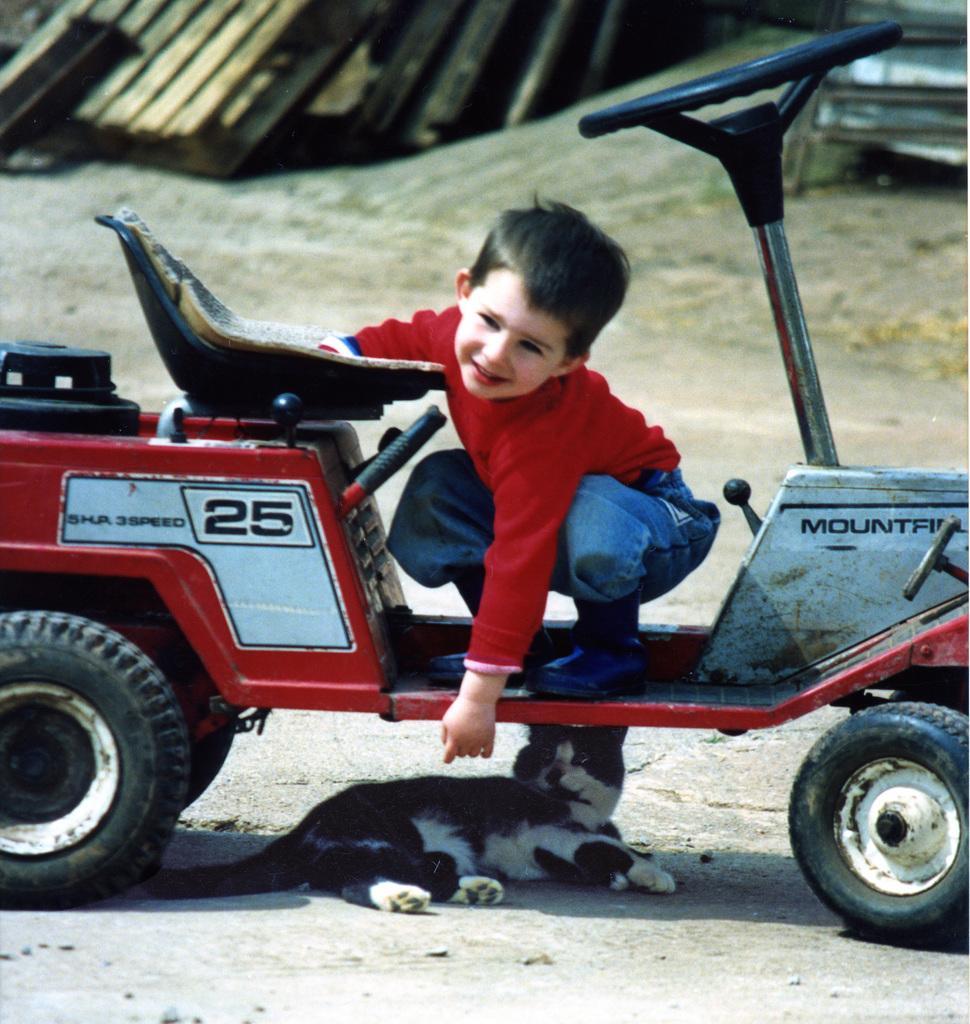In one or two sentences, can you explain what this image depicts? In this picture there is a small boy in the center of the image on a vehicle and there is a cat under the vehicle and there are wooden boards at the top side of the image. 